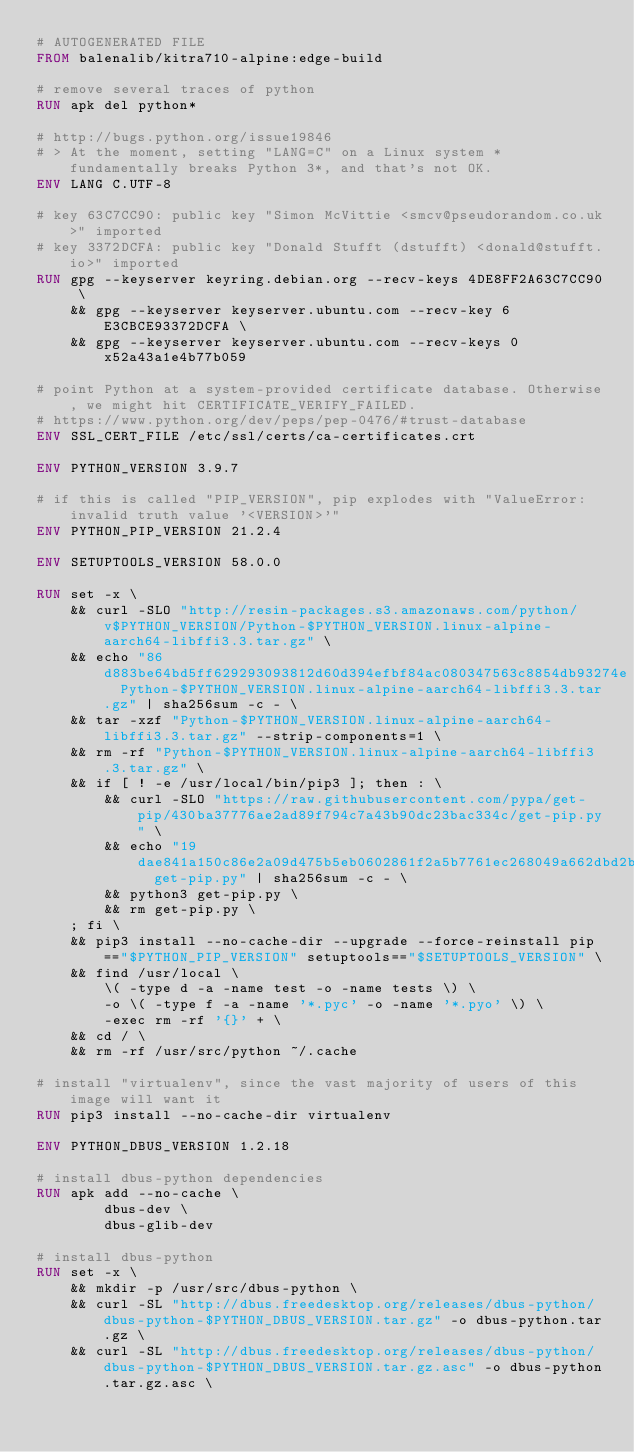Convert code to text. <code><loc_0><loc_0><loc_500><loc_500><_Dockerfile_># AUTOGENERATED FILE
FROM balenalib/kitra710-alpine:edge-build

# remove several traces of python
RUN apk del python*

# http://bugs.python.org/issue19846
# > At the moment, setting "LANG=C" on a Linux system *fundamentally breaks Python 3*, and that's not OK.
ENV LANG C.UTF-8

# key 63C7CC90: public key "Simon McVittie <smcv@pseudorandom.co.uk>" imported
# key 3372DCFA: public key "Donald Stufft (dstufft) <donald@stufft.io>" imported
RUN gpg --keyserver keyring.debian.org --recv-keys 4DE8FF2A63C7CC90 \
	&& gpg --keyserver keyserver.ubuntu.com --recv-key 6E3CBCE93372DCFA \
	&& gpg --keyserver keyserver.ubuntu.com --recv-keys 0x52a43a1e4b77b059

# point Python at a system-provided certificate database. Otherwise, we might hit CERTIFICATE_VERIFY_FAILED.
# https://www.python.org/dev/peps/pep-0476/#trust-database
ENV SSL_CERT_FILE /etc/ssl/certs/ca-certificates.crt

ENV PYTHON_VERSION 3.9.7

# if this is called "PIP_VERSION", pip explodes with "ValueError: invalid truth value '<VERSION>'"
ENV PYTHON_PIP_VERSION 21.2.4

ENV SETUPTOOLS_VERSION 58.0.0

RUN set -x \
	&& curl -SLO "http://resin-packages.s3.amazonaws.com/python/v$PYTHON_VERSION/Python-$PYTHON_VERSION.linux-alpine-aarch64-libffi3.3.tar.gz" \
	&& echo "86d883be64bd5ff629293093812d60d394efbf84ac080347563c8854db93274e  Python-$PYTHON_VERSION.linux-alpine-aarch64-libffi3.3.tar.gz" | sha256sum -c - \
	&& tar -xzf "Python-$PYTHON_VERSION.linux-alpine-aarch64-libffi3.3.tar.gz" --strip-components=1 \
	&& rm -rf "Python-$PYTHON_VERSION.linux-alpine-aarch64-libffi3.3.tar.gz" \
	&& if [ ! -e /usr/local/bin/pip3 ]; then : \
		&& curl -SLO "https://raw.githubusercontent.com/pypa/get-pip/430ba37776ae2ad89f794c7a43b90dc23bac334c/get-pip.py" \
		&& echo "19dae841a150c86e2a09d475b5eb0602861f2a5b7761ec268049a662dbd2bd0c  get-pip.py" | sha256sum -c - \
		&& python3 get-pip.py \
		&& rm get-pip.py \
	; fi \
	&& pip3 install --no-cache-dir --upgrade --force-reinstall pip=="$PYTHON_PIP_VERSION" setuptools=="$SETUPTOOLS_VERSION" \
	&& find /usr/local \
		\( -type d -a -name test -o -name tests \) \
		-o \( -type f -a -name '*.pyc' -o -name '*.pyo' \) \
		-exec rm -rf '{}' + \
	&& cd / \
	&& rm -rf /usr/src/python ~/.cache

# install "virtualenv", since the vast majority of users of this image will want it
RUN pip3 install --no-cache-dir virtualenv

ENV PYTHON_DBUS_VERSION 1.2.18

# install dbus-python dependencies 
RUN apk add --no-cache \
		dbus-dev \
		dbus-glib-dev

# install dbus-python
RUN set -x \
	&& mkdir -p /usr/src/dbus-python \
	&& curl -SL "http://dbus.freedesktop.org/releases/dbus-python/dbus-python-$PYTHON_DBUS_VERSION.tar.gz" -o dbus-python.tar.gz \
	&& curl -SL "http://dbus.freedesktop.org/releases/dbus-python/dbus-python-$PYTHON_DBUS_VERSION.tar.gz.asc" -o dbus-python.tar.gz.asc \</code> 